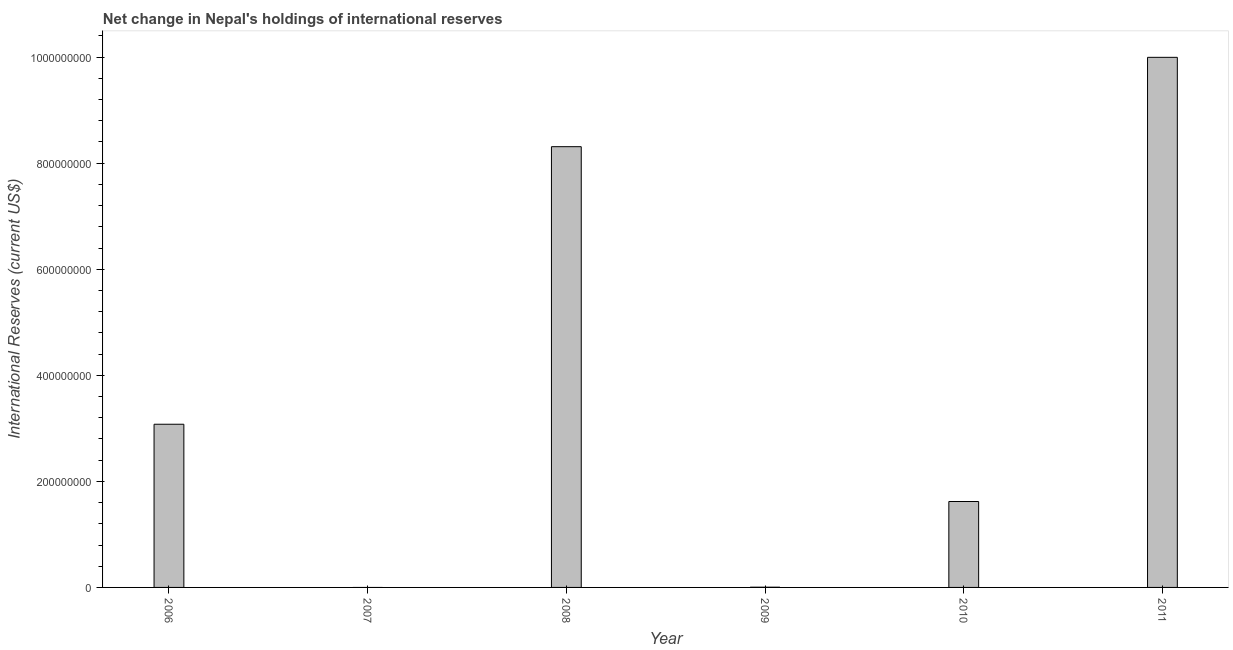Does the graph contain grids?
Provide a short and direct response. No. What is the title of the graph?
Your answer should be very brief. Net change in Nepal's holdings of international reserves. What is the label or title of the Y-axis?
Your response must be concise. International Reserves (current US$). What is the reserves and related items in 2009?
Your answer should be compact. 3.94e+05. Across all years, what is the maximum reserves and related items?
Offer a terse response. 1.00e+09. In which year was the reserves and related items maximum?
Your response must be concise. 2011. What is the sum of the reserves and related items?
Make the answer very short. 2.30e+09. What is the difference between the reserves and related items in 2006 and 2008?
Provide a succinct answer. -5.23e+08. What is the average reserves and related items per year?
Your response must be concise. 3.83e+08. What is the median reserves and related items?
Provide a succinct answer. 2.35e+08. What is the ratio of the reserves and related items in 2006 to that in 2010?
Your answer should be very brief. 1.9. Is the reserves and related items in 2006 less than that in 2009?
Provide a short and direct response. No. Is the difference between the reserves and related items in 2010 and 2011 greater than the difference between any two years?
Your response must be concise. No. What is the difference between the highest and the second highest reserves and related items?
Offer a very short reply. 1.69e+08. What is the difference between the highest and the lowest reserves and related items?
Keep it short and to the point. 1.00e+09. In how many years, is the reserves and related items greater than the average reserves and related items taken over all years?
Ensure brevity in your answer.  2. How many bars are there?
Your response must be concise. 5. How many years are there in the graph?
Provide a short and direct response. 6. What is the difference between two consecutive major ticks on the Y-axis?
Ensure brevity in your answer.  2.00e+08. Are the values on the major ticks of Y-axis written in scientific E-notation?
Your answer should be very brief. No. What is the International Reserves (current US$) in 2006?
Offer a terse response. 3.08e+08. What is the International Reserves (current US$) of 2008?
Keep it short and to the point. 8.31e+08. What is the International Reserves (current US$) in 2009?
Your answer should be very brief. 3.94e+05. What is the International Reserves (current US$) in 2010?
Give a very brief answer. 1.62e+08. What is the International Reserves (current US$) of 2011?
Offer a very short reply. 1.00e+09. What is the difference between the International Reserves (current US$) in 2006 and 2008?
Your answer should be compact. -5.23e+08. What is the difference between the International Reserves (current US$) in 2006 and 2009?
Ensure brevity in your answer.  3.07e+08. What is the difference between the International Reserves (current US$) in 2006 and 2010?
Offer a very short reply. 1.46e+08. What is the difference between the International Reserves (current US$) in 2006 and 2011?
Offer a terse response. -6.92e+08. What is the difference between the International Reserves (current US$) in 2008 and 2009?
Provide a short and direct response. 8.31e+08. What is the difference between the International Reserves (current US$) in 2008 and 2010?
Keep it short and to the point. 6.69e+08. What is the difference between the International Reserves (current US$) in 2008 and 2011?
Your response must be concise. -1.69e+08. What is the difference between the International Reserves (current US$) in 2009 and 2010?
Offer a very short reply. -1.62e+08. What is the difference between the International Reserves (current US$) in 2009 and 2011?
Provide a short and direct response. -9.99e+08. What is the difference between the International Reserves (current US$) in 2010 and 2011?
Keep it short and to the point. -8.38e+08. What is the ratio of the International Reserves (current US$) in 2006 to that in 2008?
Offer a very short reply. 0.37. What is the ratio of the International Reserves (current US$) in 2006 to that in 2009?
Offer a terse response. 781.18. What is the ratio of the International Reserves (current US$) in 2006 to that in 2010?
Ensure brevity in your answer.  1.9. What is the ratio of the International Reserves (current US$) in 2006 to that in 2011?
Make the answer very short. 0.31. What is the ratio of the International Reserves (current US$) in 2008 to that in 2009?
Your answer should be compact. 2109.94. What is the ratio of the International Reserves (current US$) in 2008 to that in 2010?
Provide a succinct answer. 5.13. What is the ratio of the International Reserves (current US$) in 2008 to that in 2011?
Your answer should be very brief. 0.83. What is the ratio of the International Reserves (current US$) in 2009 to that in 2010?
Provide a succinct answer. 0. What is the ratio of the International Reserves (current US$) in 2010 to that in 2011?
Your answer should be very brief. 0.16. 